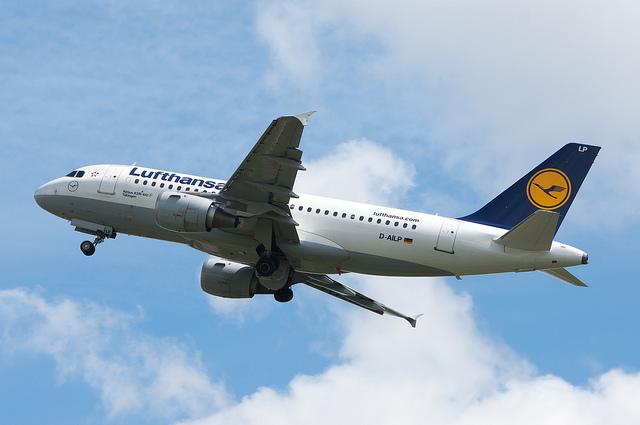What color is the planes tail end?
Short answer required. Blue. Is this plane in the air already?
Concise answer only. Yes. Have the wheels been put away on the plane yet?
Keep it brief. No. 